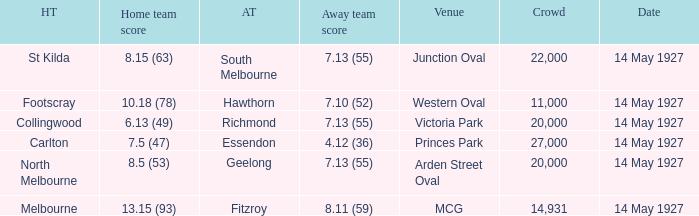How much is the sum of every crowd in attendance when the away score was 7.13 (55) for Richmond? 20000.0. 